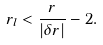<formula> <loc_0><loc_0><loc_500><loc_500>r _ { l } < \frac { r } { | \delta r | } - 2 .</formula> 